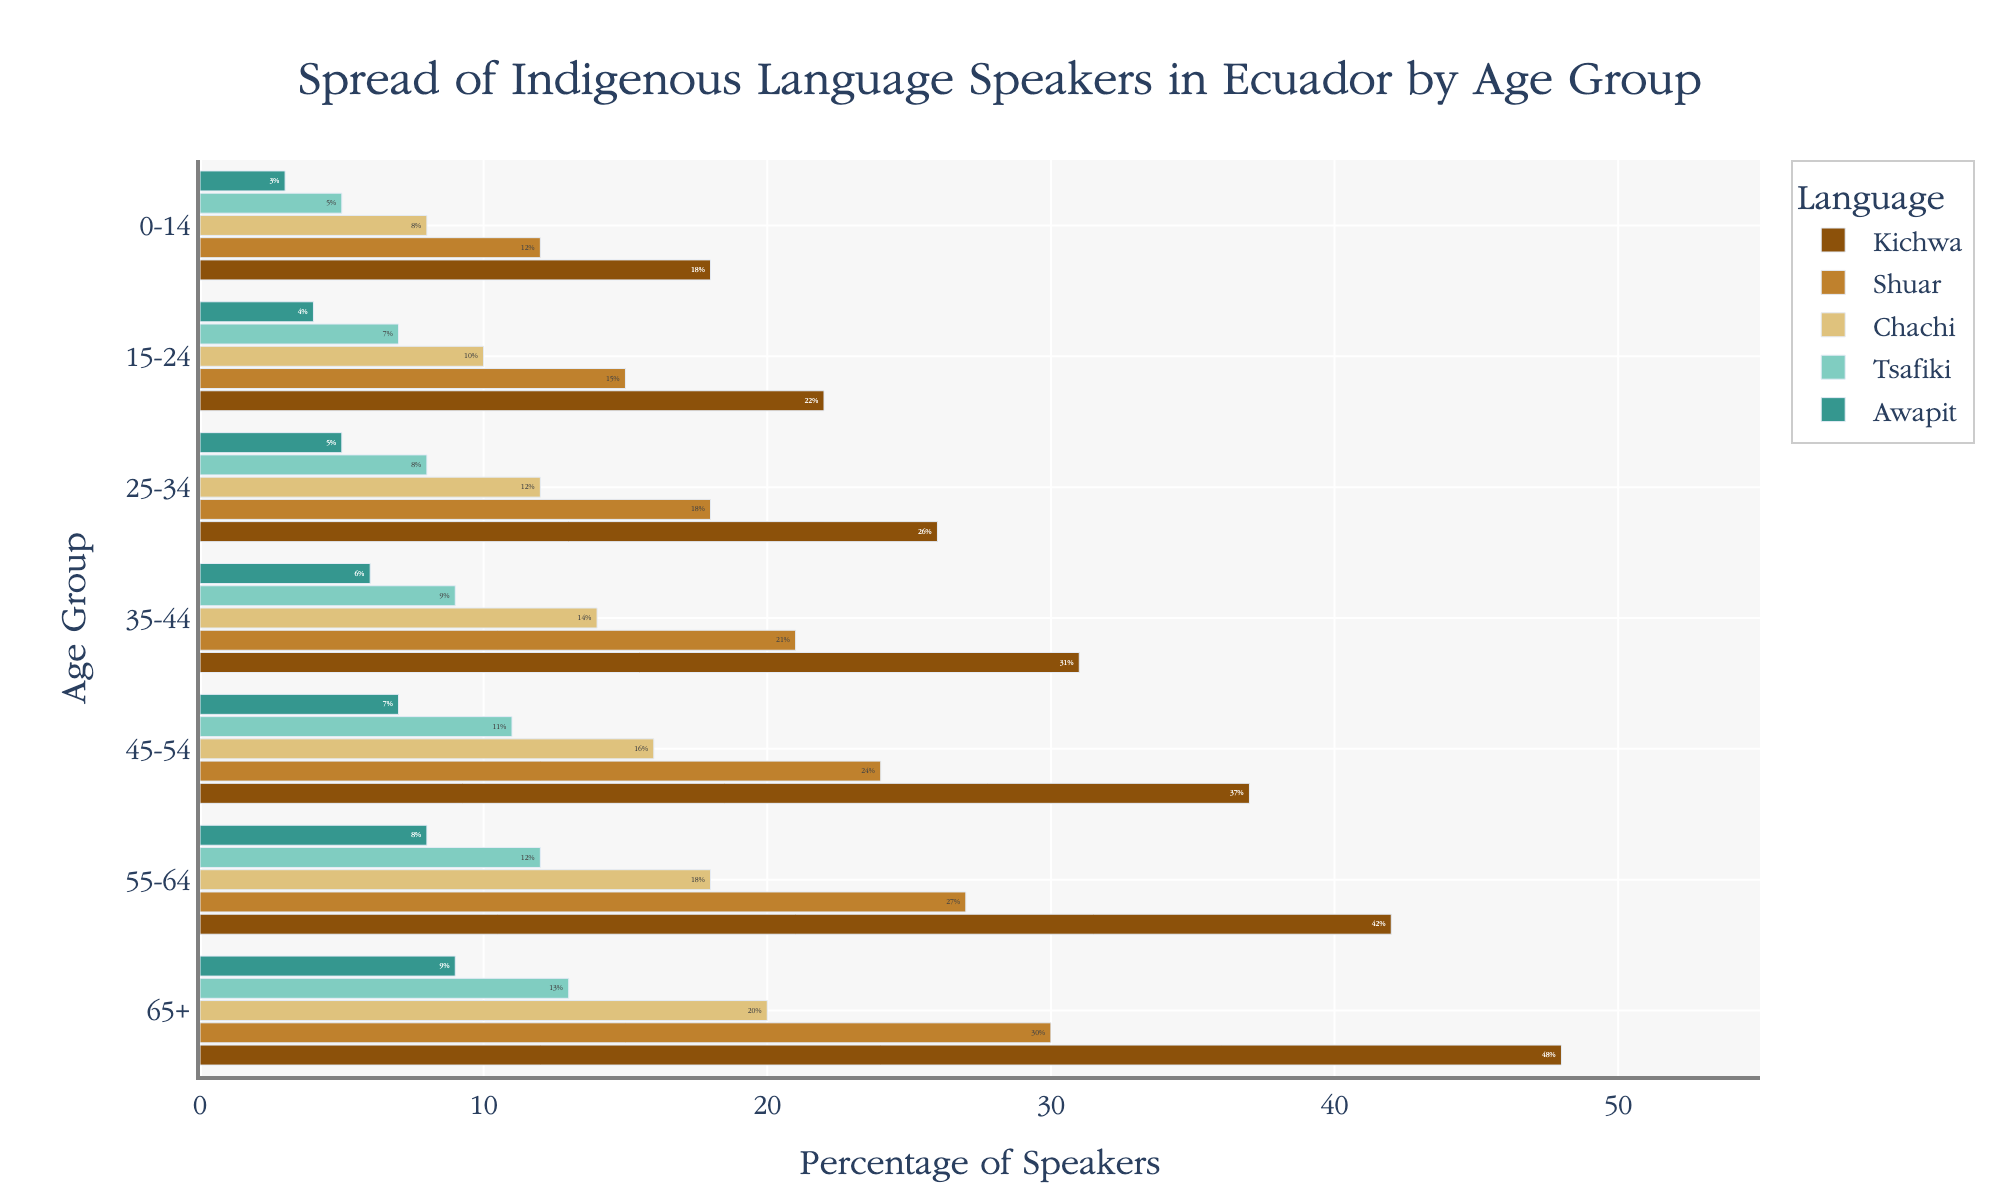What is the title of the plot? The title is located at the top of the plot and provides a succinct description of what the plot represents.
Answer: Spread of Indigenous Language Speakers in Ecuador by Age Group Which age group has the highest percentage of Kichwa speakers? By analyzing the horizontal bars representing Kichwa speakers, we can identify the age group with the longest bar in the plot.
Answer: 65+ How does the percentage of Shuar speakers change with age? By observing the length of the horizontal bars corresponding to the Shuar language across different age groups, we can describe the trend of rise or fall in percentages.
Answer: It increases with age What is the combined percentage of Tsafiki and Awapit speakers in the 25-34 age group? First, note the percentage values for Tsafiki and Awapit in the 25-34 age group. Then, sum these values.
Answer: 13% (8% + 5%) Which indigenous language has the smallest percentage of speakers among those aged 0-14? Comparing the bar lengths for the 0-14 age group across all languages, identify the smallest percentage.
Answer: Awapit For the 55-64 age group, how does the percentage of Chachi speakers compare to Kichwa speakers? Examine the bar lengths for Chachi and Kichwa in the 55-64 age group. The relative lengths reflect their percentages.
Answer: Kichwa is higher than Chachi What is the median percentage of Tsafiki speakers across all age groups? List all percentages of Tsafiki speakers across the age groups and sort them. The median is the middle value in this sorted list.
Answer: 9% How does the spread of language speakers reflect historical trends in language preservation among different age groups? Compare the trends in percentages for each language across the age groups. Older age groups generally indicate longer preservation.
Answer: Older groups tend to show higher percentages, suggesting successful preservation among older generations Which language shows the most uniform distribution of speakers across all age groups? By comparing the relative consistency of bar lengths for each language across the age groups, we can identify which one shows the least variation.
Answer: Kichwa 